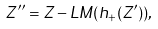<formula> <loc_0><loc_0><loc_500><loc_500>Z ^ { \prime \prime } = Z - L M ( h _ { + } ( Z ^ { \prime } ) ) ,</formula> 